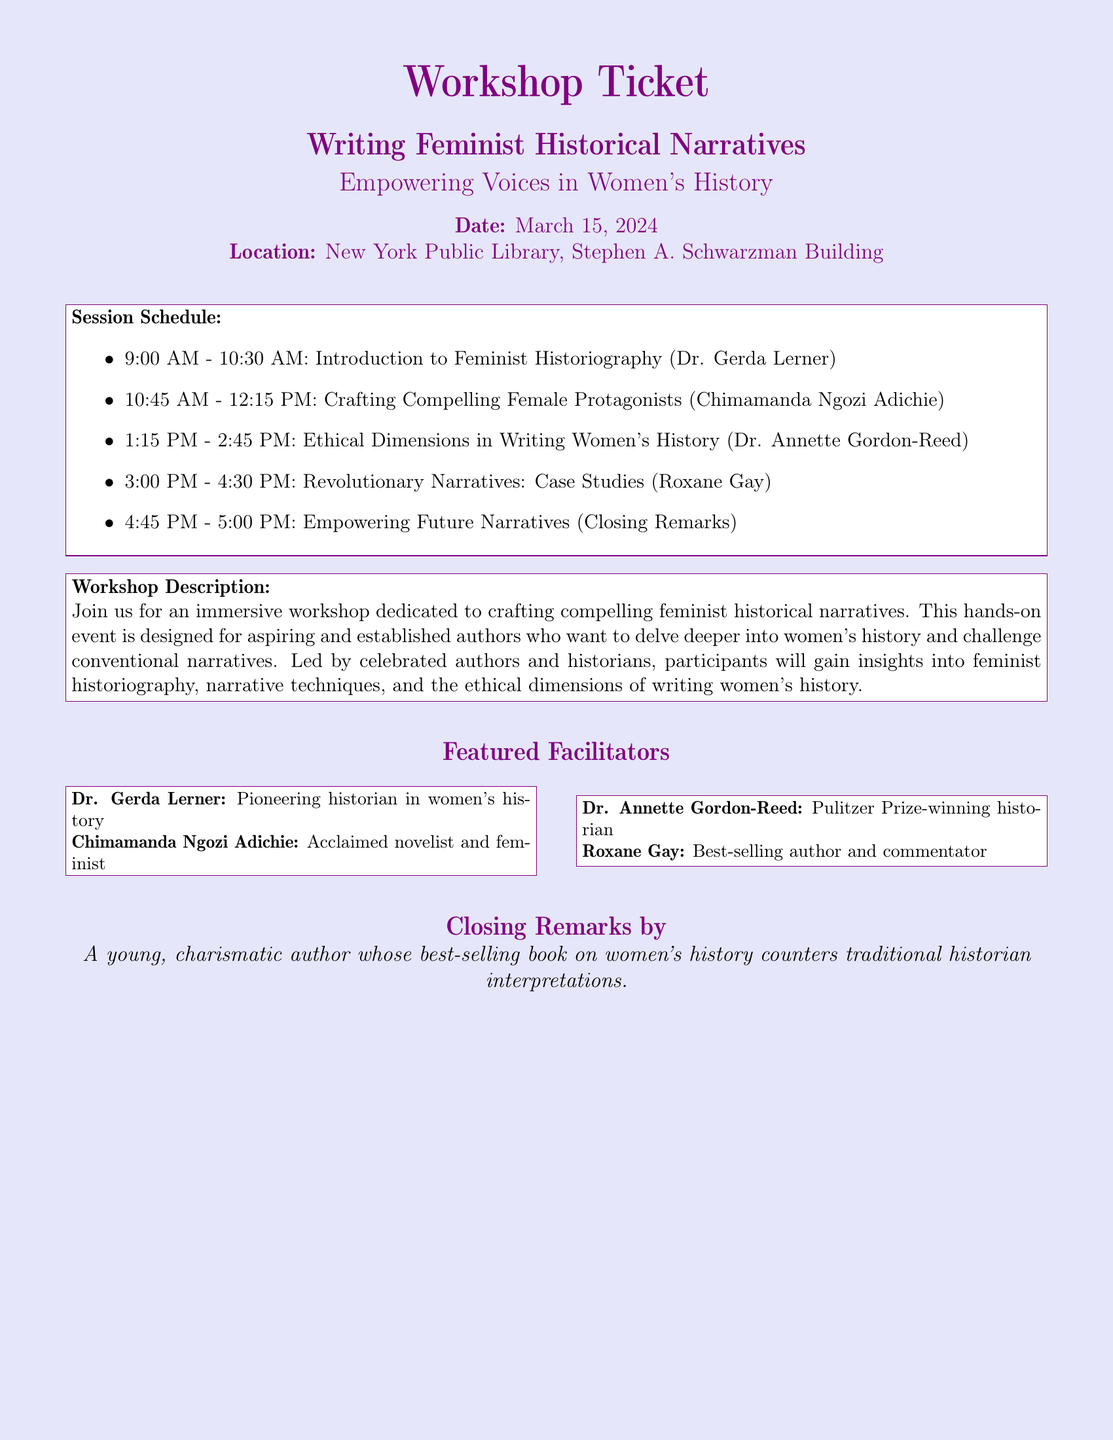What is the date of the workshop? The date of the workshop is provided in the document as March 15, 2024.
Answer: March 15, 2024 Where is the workshop being held? The location of the workshop is specified in the document as New York Public Library, Stephen A. Schwarzman Building.
Answer: New York Public Library, Stephen A. Schwarzman Building Who is facilitating the session on Ethical Dimensions in Writing Women's History? The document lists Dr. Annette Gordon-Reed as the facilitator for this specific session.
Answer: Dr. Annette Gordon-Reed What time does the session on Crafting Compelling Female Protagonists start? The starting time of this session can be determined from the schedule in the document, which indicates it begins at 10:45 AM.
Answer: 10:45 AM How many sessions are scheduled between 9 AM and 4:30 PM? The document outlines four distinct sessions occurring during this timeframe.
Answer: Four What role does the closing remarks speaker play in the workshop? The speaker closing the workshop is described as a young, charismatic author countering traditional historian interpretations, reflecting their involvement in women's history narratives.
Answer: A young, charismatic author Which facilitator is a Pulitzer Prize-winning historian? The document identifies Dr. Annette Gordon-Reed as a Pulitzer Prize-winning historian.
Answer: Dr. Annette Gordon-Reed What is the main theme of the workshop? The workshop is centered around the theme of crafting feminist historical narratives, as stated in the title and description.
Answer: Writing Feminist Historical Narratives 